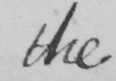What is written in this line of handwriting? the 